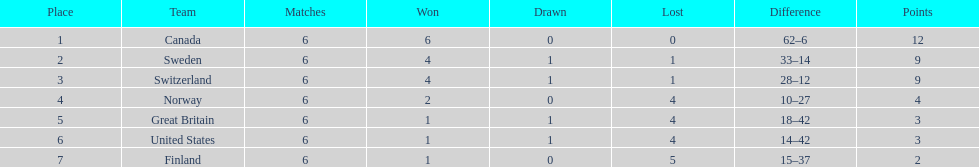In which nation did the united states rank higher than? Finland. 